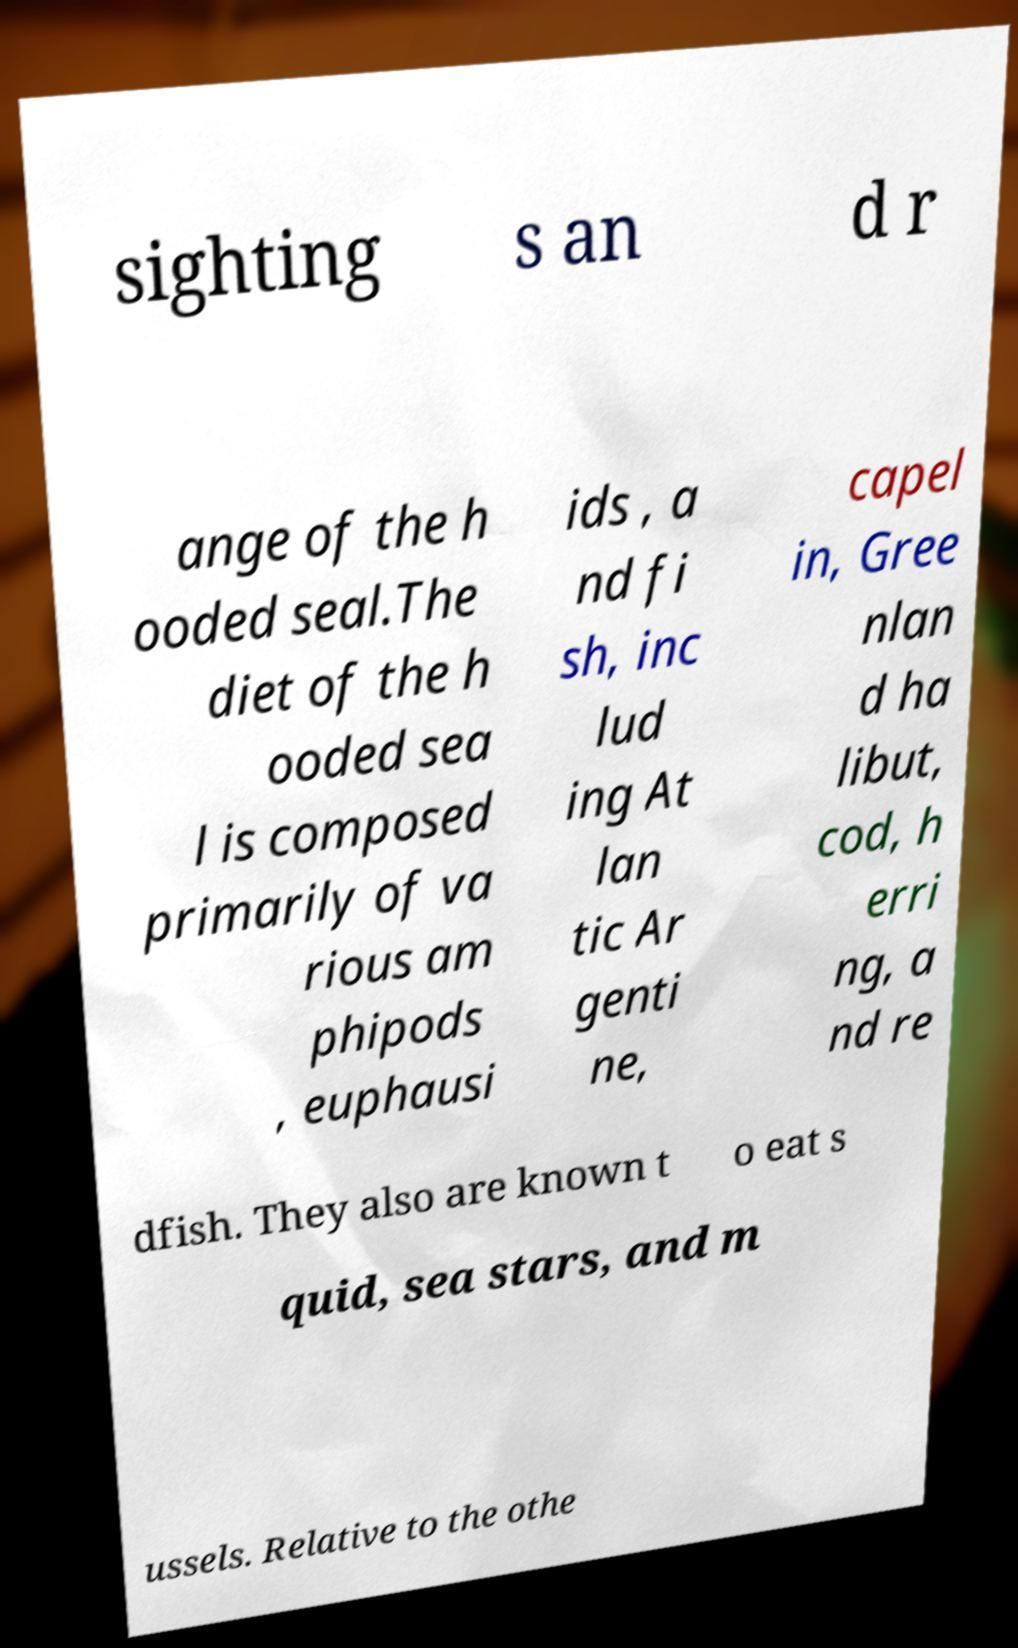For documentation purposes, I need the text within this image transcribed. Could you provide that? sighting s an d r ange of the h ooded seal.The diet of the h ooded sea l is composed primarily of va rious am phipods , euphausi ids , a nd fi sh, inc lud ing At lan tic Ar genti ne, capel in, Gree nlan d ha libut, cod, h erri ng, a nd re dfish. They also are known t o eat s quid, sea stars, and m ussels. Relative to the othe 